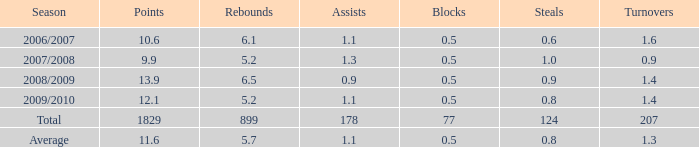What is the count of blocks when there are under 5.2 rebounds? 0.0. 